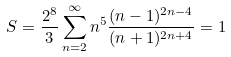<formula> <loc_0><loc_0><loc_500><loc_500>S = \frac { 2 ^ { 8 } } { 3 } \sum _ { n = 2 } ^ { \infty } n ^ { 5 } \frac { ( n - 1 ) ^ { 2 n - 4 } } { ( n + 1 ) ^ { 2 n + 4 } } = 1</formula> 